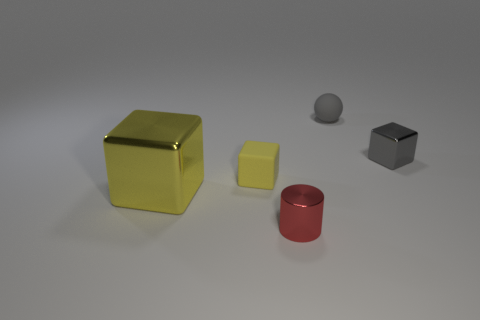The red object in front of the gray thing behind the tiny gray thing that is right of the small gray ball is what shape?
Your answer should be very brief. Cylinder. Is the number of small red metallic cylinders greater than the number of small rubber objects?
Your response must be concise. No. Is there a large blue cube?
Your response must be concise. No. How many things are either tiny metallic things that are on the left side of the small gray rubber object or red metallic things that are on the right side of the small yellow object?
Your answer should be very brief. 1. Is the color of the tiny sphere the same as the tiny metal block?
Offer a very short reply. Yes. Are there fewer tiny gray things than small red cylinders?
Your answer should be compact. No. Are there any tiny gray spheres on the left side of the tiny rubber block?
Your answer should be compact. No. Is the material of the big cube the same as the gray sphere?
Give a very brief answer. No. What color is the small matte object that is the same shape as the large yellow object?
Keep it short and to the point. Yellow. Does the metal cube that is on the right side of the gray matte thing have the same color as the tiny shiny cylinder?
Keep it short and to the point. No. 